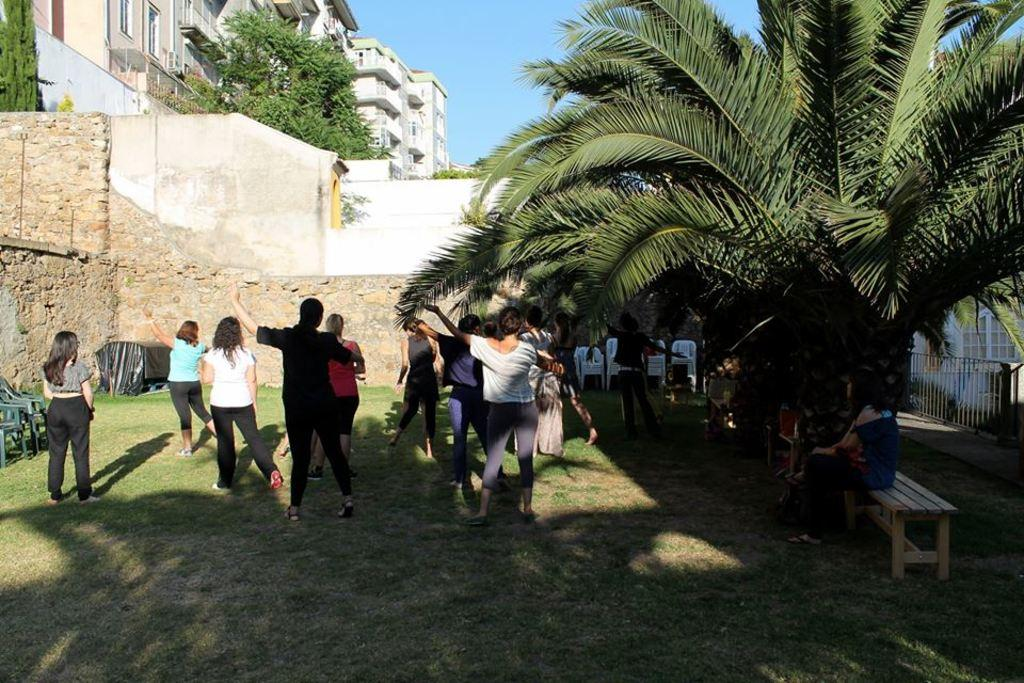How many people are visible in the image? There are persons standing in the image. What can be seen in the background of the image? There is a sky, a building, trees, a wall, a gate, chairs, and grass visible in the background. Are there any people sitting in the image? Yes, there are persons sitting on a bench in the background. What type of wine is being served on the sofa in the image? There is no sofa or wine present in the image. How many times do the persons in the image sneeze? There is no indication of anyone sneezing in the image. 